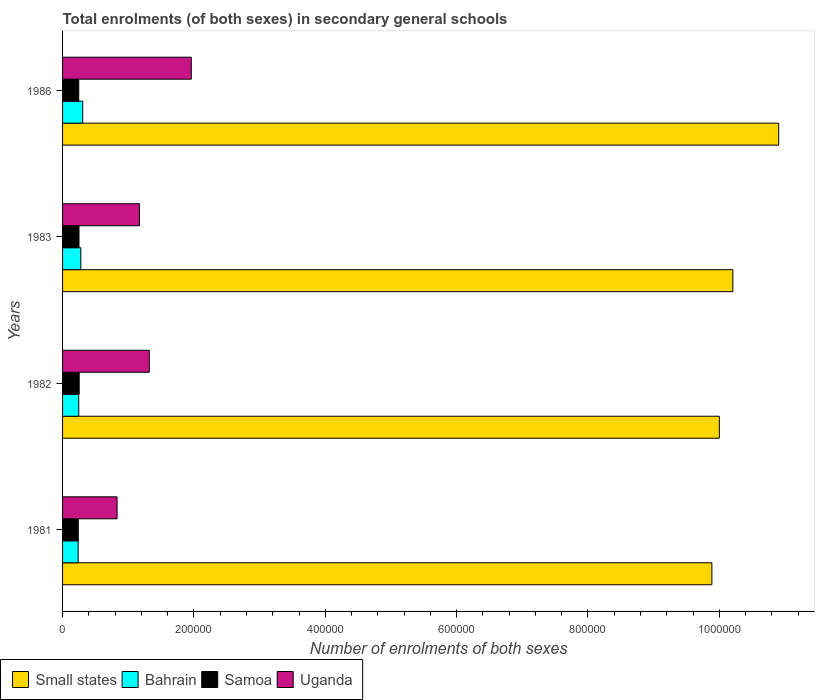Are the number of bars on each tick of the Y-axis equal?
Make the answer very short. Yes. How many bars are there on the 2nd tick from the top?
Provide a succinct answer. 4. What is the label of the 2nd group of bars from the top?
Keep it short and to the point. 1983. In how many cases, is the number of bars for a given year not equal to the number of legend labels?
Provide a short and direct response. 0. What is the number of enrolments in secondary schools in Uganda in 1983?
Offer a terse response. 1.17e+05. Across all years, what is the maximum number of enrolments in secondary schools in Small states?
Offer a very short reply. 1.09e+06. Across all years, what is the minimum number of enrolments in secondary schools in Samoa?
Your answer should be compact. 2.40e+04. In which year was the number of enrolments in secondary schools in Bahrain minimum?
Your answer should be very brief. 1981. What is the total number of enrolments in secondary schools in Samoa in the graph?
Give a very brief answer. 9.90e+04. What is the difference between the number of enrolments in secondary schools in Samoa in 1981 and that in 1983?
Provide a short and direct response. -1043. What is the difference between the number of enrolments in secondary schools in Uganda in 1981 and the number of enrolments in secondary schools in Small states in 1982?
Keep it short and to the point. -9.17e+05. What is the average number of enrolments in secondary schools in Small states per year?
Offer a very short reply. 1.02e+06. In the year 1981, what is the difference between the number of enrolments in secondary schools in Bahrain and number of enrolments in secondary schools in Small states?
Your answer should be very brief. -9.65e+05. What is the ratio of the number of enrolments in secondary schools in Uganda in 1983 to that in 1986?
Offer a very short reply. 0.6. Is the number of enrolments in secondary schools in Samoa in 1981 less than that in 1982?
Keep it short and to the point. Yes. What is the difference between the highest and the second highest number of enrolments in secondary schools in Small states?
Keep it short and to the point. 6.98e+04. What is the difference between the highest and the lowest number of enrolments in secondary schools in Samoa?
Provide a succinct answer. 1372. In how many years, is the number of enrolments in secondary schools in Bahrain greater than the average number of enrolments in secondary schools in Bahrain taken over all years?
Your answer should be compact. 2. Is the sum of the number of enrolments in secondary schools in Bahrain in 1981 and 1983 greater than the maximum number of enrolments in secondary schools in Uganda across all years?
Provide a succinct answer. No. What does the 3rd bar from the top in 1982 represents?
Your answer should be compact. Bahrain. What does the 4th bar from the bottom in 1983 represents?
Provide a succinct answer. Uganda. Is it the case that in every year, the sum of the number of enrolments in secondary schools in Bahrain and number of enrolments in secondary schools in Small states is greater than the number of enrolments in secondary schools in Samoa?
Ensure brevity in your answer.  Yes. How many years are there in the graph?
Provide a short and direct response. 4. What is the difference between two consecutive major ticks on the X-axis?
Make the answer very short. 2.00e+05. Does the graph contain grids?
Ensure brevity in your answer.  No. What is the title of the graph?
Give a very brief answer. Total enrolments (of both sexes) in secondary general schools. Does "Slovenia" appear as one of the legend labels in the graph?
Your answer should be compact. No. What is the label or title of the X-axis?
Ensure brevity in your answer.  Number of enrolments of both sexes. What is the Number of enrolments of both sexes of Small states in 1981?
Provide a succinct answer. 9.89e+05. What is the Number of enrolments of both sexes of Bahrain in 1981?
Ensure brevity in your answer.  2.37e+04. What is the Number of enrolments of both sexes of Samoa in 1981?
Keep it short and to the point. 2.40e+04. What is the Number of enrolments of both sexes of Uganda in 1981?
Provide a succinct answer. 8.30e+04. What is the Number of enrolments of both sexes of Small states in 1982?
Offer a terse response. 1.00e+06. What is the Number of enrolments of both sexes in Bahrain in 1982?
Keep it short and to the point. 2.46e+04. What is the Number of enrolments of both sexes of Samoa in 1982?
Provide a succinct answer. 2.53e+04. What is the Number of enrolments of both sexes in Uganda in 1982?
Ensure brevity in your answer.  1.32e+05. What is the Number of enrolments of both sexes of Small states in 1983?
Ensure brevity in your answer.  1.02e+06. What is the Number of enrolments of both sexes of Bahrain in 1983?
Provide a succinct answer. 2.78e+04. What is the Number of enrolments of both sexes in Samoa in 1983?
Your answer should be compact. 2.50e+04. What is the Number of enrolments of both sexes in Uganda in 1983?
Give a very brief answer. 1.17e+05. What is the Number of enrolments of both sexes of Small states in 1986?
Provide a succinct answer. 1.09e+06. What is the Number of enrolments of both sexes of Bahrain in 1986?
Ensure brevity in your answer.  3.07e+04. What is the Number of enrolments of both sexes in Samoa in 1986?
Give a very brief answer. 2.47e+04. What is the Number of enrolments of both sexes of Uganda in 1986?
Offer a terse response. 1.96e+05. Across all years, what is the maximum Number of enrolments of both sexes in Small states?
Provide a short and direct response. 1.09e+06. Across all years, what is the maximum Number of enrolments of both sexes in Bahrain?
Offer a terse response. 3.07e+04. Across all years, what is the maximum Number of enrolments of both sexes of Samoa?
Your response must be concise. 2.53e+04. Across all years, what is the maximum Number of enrolments of both sexes of Uganda?
Give a very brief answer. 1.96e+05. Across all years, what is the minimum Number of enrolments of both sexes in Small states?
Your response must be concise. 9.89e+05. Across all years, what is the minimum Number of enrolments of both sexes of Bahrain?
Your answer should be compact. 2.37e+04. Across all years, what is the minimum Number of enrolments of both sexes of Samoa?
Keep it short and to the point. 2.40e+04. Across all years, what is the minimum Number of enrolments of both sexes of Uganda?
Offer a very short reply. 8.30e+04. What is the total Number of enrolments of both sexes in Small states in the graph?
Your answer should be compact. 4.10e+06. What is the total Number of enrolments of both sexes in Bahrain in the graph?
Your answer should be very brief. 1.07e+05. What is the total Number of enrolments of both sexes of Samoa in the graph?
Keep it short and to the point. 9.90e+04. What is the total Number of enrolments of both sexes in Uganda in the graph?
Ensure brevity in your answer.  5.28e+05. What is the difference between the Number of enrolments of both sexes of Small states in 1981 and that in 1982?
Your answer should be compact. -1.13e+04. What is the difference between the Number of enrolments of both sexes in Bahrain in 1981 and that in 1982?
Provide a succinct answer. -929. What is the difference between the Number of enrolments of both sexes of Samoa in 1981 and that in 1982?
Your answer should be compact. -1372. What is the difference between the Number of enrolments of both sexes of Uganda in 1981 and that in 1982?
Provide a short and direct response. -4.91e+04. What is the difference between the Number of enrolments of both sexes in Small states in 1981 and that in 1983?
Offer a terse response. -3.19e+04. What is the difference between the Number of enrolments of both sexes in Bahrain in 1981 and that in 1983?
Give a very brief answer. -4067. What is the difference between the Number of enrolments of both sexes in Samoa in 1981 and that in 1983?
Your answer should be compact. -1043. What is the difference between the Number of enrolments of both sexes of Uganda in 1981 and that in 1983?
Your answer should be compact. -3.41e+04. What is the difference between the Number of enrolments of both sexes of Small states in 1981 and that in 1986?
Give a very brief answer. -1.02e+05. What is the difference between the Number of enrolments of both sexes of Bahrain in 1981 and that in 1986?
Ensure brevity in your answer.  -6989. What is the difference between the Number of enrolments of both sexes of Samoa in 1981 and that in 1986?
Provide a short and direct response. -690. What is the difference between the Number of enrolments of both sexes of Uganda in 1981 and that in 1986?
Your answer should be compact. -1.13e+05. What is the difference between the Number of enrolments of both sexes in Small states in 1982 and that in 1983?
Your answer should be compact. -2.06e+04. What is the difference between the Number of enrolments of both sexes in Bahrain in 1982 and that in 1983?
Provide a short and direct response. -3138. What is the difference between the Number of enrolments of both sexes of Samoa in 1982 and that in 1983?
Offer a terse response. 329. What is the difference between the Number of enrolments of both sexes of Uganda in 1982 and that in 1983?
Your answer should be compact. 1.50e+04. What is the difference between the Number of enrolments of both sexes in Small states in 1982 and that in 1986?
Your answer should be very brief. -9.04e+04. What is the difference between the Number of enrolments of both sexes in Bahrain in 1982 and that in 1986?
Keep it short and to the point. -6060. What is the difference between the Number of enrolments of both sexes of Samoa in 1982 and that in 1986?
Provide a short and direct response. 682. What is the difference between the Number of enrolments of both sexes of Uganda in 1982 and that in 1986?
Offer a terse response. -6.40e+04. What is the difference between the Number of enrolments of both sexes of Small states in 1983 and that in 1986?
Offer a terse response. -6.98e+04. What is the difference between the Number of enrolments of both sexes of Bahrain in 1983 and that in 1986?
Your answer should be very brief. -2922. What is the difference between the Number of enrolments of both sexes in Samoa in 1983 and that in 1986?
Offer a very short reply. 353. What is the difference between the Number of enrolments of both sexes of Uganda in 1983 and that in 1986?
Offer a very short reply. -7.89e+04. What is the difference between the Number of enrolments of both sexes in Small states in 1981 and the Number of enrolments of both sexes in Bahrain in 1982?
Ensure brevity in your answer.  9.64e+05. What is the difference between the Number of enrolments of both sexes of Small states in 1981 and the Number of enrolments of both sexes of Samoa in 1982?
Your answer should be very brief. 9.63e+05. What is the difference between the Number of enrolments of both sexes in Small states in 1981 and the Number of enrolments of both sexes in Uganda in 1982?
Provide a short and direct response. 8.57e+05. What is the difference between the Number of enrolments of both sexes in Bahrain in 1981 and the Number of enrolments of both sexes in Samoa in 1982?
Make the answer very short. -1623. What is the difference between the Number of enrolments of both sexes of Bahrain in 1981 and the Number of enrolments of both sexes of Uganda in 1982?
Keep it short and to the point. -1.08e+05. What is the difference between the Number of enrolments of both sexes of Samoa in 1981 and the Number of enrolments of both sexes of Uganda in 1982?
Your response must be concise. -1.08e+05. What is the difference between the Number of enrolments of both sexes of Small states in 1981 and the Number of enrolments of both sexes of Bahrain in 1983?
Your response must be concise. 9.61e+05. What is the difference between the Number of enrolments of both sexes in Small states in 1981 and the Number of enrolments of both sexes in Samoa in 1983?
Keep it short and to the point. 9.64e+05. What is the difference between the Number of enrolments of both sexes in Small states in 1981 and the Number of enrolments of both sexes in Uganda in 1983?
Your response must be concise. 8.72e+05. What is the difference between the Number of enrolments of both sexes of Bahrain in 1981 and the Number of enrolments of both sexes of Samoa in 1983?
Provide a succinct answer. -1294. What is the difference between the Number of enrolments of both sexes in Bahrain in 1981 and the Number of enrolments of both sexes in Uganda in 1983?
Offer a terse response. -9.34e+04. What is the difference between the Number of enrolments of both sexes in Samoa in 1981 and the Number of enrolments of both sexes in Uganda in 1983?
Your answer should be compact. -9.31e+04. What is the difference between the Number of enrolments of both sexes in Small states in 1981 and the Number of enrolments of both sexes in Bahrain in 1986?
Give a very brief answer. 9.58e+05. What is the difference between the Number of enrolments of both sexes of Small states in 1981 and the Number of enrolments of both sexes of Samoa in 1986?
Give a very brief answer. 9.64e+05. What is the difference between the Number of enrolments of both sexes of Small states in 1981 and the Number of enrolments of both sexes of Uganda in 1986?
Offer a terse response. 7.93e+05. What is the difference between the Number of enrolments of both sexes in Bahrain in 1981 and the Number of enrolments of both sexes in Samoa in 1986?
Provide a succinct answer. -941. What is the difference between the Number of enrolments of both sexes in Bahrain in 1981 and the Number of enrolments of both sexes in Uganda in 1986?
Your answer should be very brief. -1.72e+05. What is the difference between the Number of enrolments of both sexes of Samoa in 1981 and the Number of enrolments of both sexes of Uganda in 1986?
Ensure brevity in your answer.  -1.72e+05. What is the difference between the Number of enrolments of both sexes in Small states in 1982 and the Number of enrolments of both sexes in Bahrain in 1983?
Your response must be concise. 9.72e+05. What is the difference between the Number of enrolments of both sexes of Small states in 1982 and the Number of enrolments of both sexes of Samoa in 1983?
Keep it short and to the point. 9.75e+05. What is the difference between the Number of enrolments of both sexes of Small states in 1982 and the Number of enrolments of both sexes of Uganda in 1983?
Your answer should be compact. 8.83e+05. What is the difference between the Number of enrolments of both sexes in Bahrain in 1982 and the Number of enrolments of both sexes in Samoa in 1983?
Ensure brevity in your answer.  -365. What is the difference between the Number of enrolments of both sexes in Bahrain in 1982 and the Number of enrolments of both sexes in Uganda in 1983?
Ensure brevity in your answer.  -9.24e+04. What is the difference between the Number of enrolments of both sexes in Samoa in 1982 and the Number of enrolments of both sexes in Uganda in 1983?
Give a very brief answer. -9.17e+04. What is the difference between the Number of enrolments of both sexes in Small states in 1982 and the Number of enrolments of both sexes in Bahrain in 1986?
Make the answer very short. 9.69e+05. What is the difference between the Number of enrolments of both sexes of Small states in 1982 and the Number of enrolments of both sexes of Samoa in 1986?
Offer a very short reply. 9.75e+05. What is the difference between the Number of enrolments of both sexes in Small states in 1982 and the Number of enrolments of both sexes in Uganda in 1986?
Make the answer very short. 8.04e+05. What is the difference between the Number of enrolments of both sexes in Bahrain in 1982 and the Number of enrolments of both sexes in Uganda in 1986?
Give a very brief answer. -1.71e+05. What is the difference between the Number of enrolments of both sexes of Samoa in 1982 and the Number of enrolments of both sexes of Uganda in 1986?
Keep it short and to the point. -1.71e+05. What is the difference between the Number of enrolments of both sexes in Small states in 1983 and the Number of enrolments of both sexes in Bahrain in 1986?
Your answer should be compact. 9.90e+05. What is the difference between the Number of enrolments of both sexes of Small states in 1983 and the Number of enrolments of both sexes of Samoa in 1986?
Your answer should be very brief. 9.96e+05. What is the difference between the Number of enrolments of both sexes of Small states in 1983 and the Number of enrolments of both sexes of Uganda in 1986?
Offer a terse response. 8.25e+05. What is the difference between the Number of enrolments of both sexes of Bahrain in 1983 and the Number of enrolments of both sexes of Samoa in 1986?
Give a very brief answer. 3126. What is the difference between the Number of enrolments of both sexes in Bahrain in 1983 and the Number of enrolments of both sexes in Uganda in 1986?
Provide a short and direct response. -1.68e+05. What is the difference between the Number of enrolments of both sexes in Samoa in 1983 and the Number of enrolments of both sexes in Uganda in 1986?
Make the answer very short. -1.71e+05. What is the average Number of enrolments of both sexes in Small states per year?
Offer a very short reply. 1.02e+06. What is the average Number of enrolments of both sexes of Bahrain per year?
Offer a very short reply. 2.67e+04. What is the average Number of enrolments of both sexes in Samoa per year?
Ensure brevity in your answer.  2.47e+04. What is the average Number of enrolments of both sexes in Uganda per year?
Keep it short and to the point. 1.32e+05. In the year 1981, what is the difference between the Number of enrolments of both sexes in Small states and Number of enrolments of both sexes in Bahrain?
Your answer should be compact. 9.65e+05. In the year 1981, what is the difference between the Number of enrolments of both sexes in Small states and Number of enrolments of both sexes in Samoa?
Your answer should be very brief. 9.65e+05. In the year 1981, what is the difference between the Number of enrolments of both sexes of Small states and Number of enrolments of both sexes of Uganda?
Keep it short and to the point. 9.06e+05. In the year 1981, what is the difference between the Number of enrolments of both sexes of Bahrain and Number of enrolments of both sexes of Samoa?
Provide a short and direct response. -251. In the year 1981, what is the difference between the Number of enrolments of both sexes of Bahrain and Number of enrolments of both sexes of Uganda?
Offer a terse response. -5.93e+04. In the year 1981, what is the difference between the Number of enrolments of both sexes of Samoa and Number of enrolments of both sexes of Uganda?
Make the answer very short. -5.90e+04. In the year 1982, what is the difference between the Number of enrolments of both sexes in Small states and Number of enrolments of both sexes in Bahrain?
Provide a short and direct response. 9.75e+05. In the year 1982, what is the difference between the Number of enrolments of both sexes in Small states and Number of enrolments of both sexes in Samoa?
Your response must be concise. 9.75e+05. In the year 1982, what is the difference between the Number of enrolments of both sexes of Small states and Number of enrolments of both sexes of Uganda?
Your answer should be very brief. 8.68e+05. In the year 1982, what is the difference between the Number of enrolments of both sexes in Bahrain and Number of enrolments of both sexes in Samoa?
Your answer should be very brief. -694. In the year 1982, what is the difference between the Number of enrolments of both sexes of Bahrain and Number of enrolments of both sexes of Uganda?
Provide a succinct answer. -1.07e+05. In the year 1982, what is the difference between the Number of enrolments of both sexes of Samoa and Number of enrolments of both sexes of Uganda?
Provide a short and direct response. -1.07e+05. In the year 1983, what is the difference between the Number of enrolments of both sexes of Small states and Number of enrolments of both sexes of Bahrain?
Make the answer very short. 9.93e+05. In the year 1983, what is the difference between the Number of enrolments of both sexes in Small states and Number of enrolments of both sexes in Samoa?
Your response must be concise. 9.96e+05. In the year 1983, what is the difference between the Number of enrolments of both sexes of Small states and Number of enrolments of both sexes of Uganda?
Provide a short and direct response. 9.04e+05. In the year 1983, what is the difference between the Number of enrolments of both sexes of Bahrain and Number of enrolments of both sexes of Samoa?
Your response must be concise. 2773. In the year 1983, what is the difference between the Number of enrolments of both sexes in Bahrain and Number of enrolments of both sexes in Uganda?
Make the answer very short. -8.93e+04. In the year 1983, what is the difference between the Number of enrolments of both sexes in Samoa and Number of enrolments of both sexes in Uganda?
Your answer should be compact. -9.21e+04. In the year 1986, what is the difference between the Number of enrolments of both sexes of Small states and Number of enrolments of both sexes of Bahrain?
Provide a short and direct response. 1.06e+06. In the year 1986, what is the difference between the Number of enrolments of both sexes in Small states and Number of enrolments of both sexes in Samoa?
Give a very brief answer. 1.07e+06. In the year 1986, what is the difference between the Number of enrolments of both sexes of Small states and Number of enrolments of both sexes of Uganda?
Give a very brief answer. 8.94e+05. In the year 1986, what is the difference between the Number of enrolments of both sexes of Bahrain and Number of enrolments of both sexes of Samoa?
Make the answer very short. 6048. In the year 1986, what is the difference between the Number of enrolments of both sexes of Bahrain and Number of enrolments of both sexes of Uganda?
Your answer should be very brief. -1.65e+05. In the year 1986, what is the difference between the Number of enrolments of both sexes of Samoa and Number of enrolments of both sexes of Uganda?
Keep it short and to the point. -1.71e+05. What is the ratio of the Number of enrolments of both sexes of Small states in 1981 to that in 1982?
Your answer should be very brief. 0.99. What is the ratio of the Number of enrolments of both sexes in Bahrain in 1981 to that in 1982?
Your answer should be compact. 0.96. What is the ratio of the Number of enrolments of both sexes of Samoa in 1981 to that in 1982?
Ensure brevity in your answer.  0.95. What is the ratio of the Number of enrolments of both sexes of Uganda in 1981 to that in 1982?
Your answer should be compact. 0.63. What is the ratio of the Number of enrolments of both sexes in Small states in 1981 to that in 1983?
Offer a very short reply. 0.97. What is the ratio of the Number of enrolments of both sexes of Bahrain in 1981 to that in 1983?
Make the answer very short. 0.85. What is the ratio of the Number of enrolments of both sexes of Uganda in 1981 to that in 1983?
Make the answer very short. 0.71. What is the ratio of the Number of enrolments of both sexes in Small states in 1981 to that in 1986?
Your response must be concise. 0.91. What is the ratio of the Number of enrolments of both sexes of Bahrain in 1981 to that in 1986?
Your answer should be very brief. 0.77. What is the ratio of the Number of enrolments of both sexes in Samoa in 1981 to that in 1986?
Ensure brevity in your answer.  0.97. What is the ratio of the Number of enrolments of both sexes in Uganda in 1981 to that in 1986?
Give a very brief answer. 0.42. What is the ratio of the Number of enrolments of both sexes in Small states in 1982 to that in 1983?
Provide a short and direct response. 0.98. What is the ratio of the Number of enrolments of both sexes of Bahrain in 1982 to that in 1983?
Offer a terse response. 0.89. What is the ratio of the Number of enrolments of both sexes of Samoa in 1982 to that in 1983?
Offer a very short reply. 1.01. What is the ratio of the Number of enrolments of both sexes in Uganda in 1982 to that in 1983?
Your response must be concise. 1.13. What is the ratio of the Number of enrolments of both sexes in Small states in 1982 to that in 1986?
Ensure brevity in your answer.  0.92. What is the ratio of the Number of enrolments of both sexes of Bahrain in 1982 to that in 1986?
Make the answer very short. 0.8. What is the ratio of the Number of enrolments of both sexes of Samoa in 1982 to that in 1986?
Make the answer very short. 1.03. What is the ratio of the Number of enrolments of both sexes in Uganda in 1982 to that in 1986?
Make the answer very short. 0.67. What is the ratio of the Number of enrolments of both sexes in Small states in 1983 to that in 1986?
Offer a terse response. 0.94. What is the ratio of the Number of enrolments of both sexes in Bahrain in 1983 to that in 1986?
Provide a succinct answer. 0.9. What is the ratio of the Number of enrolments of both sexes of Samoa in 1983 to that in 1986?
Your response must be concise. 1.01. What is the ratio of the Number of enrolments of both sexes in Uganda in 1983 to that in 1986?
Make the answer very short. 0.6. What is the difference between the highest and the second highest Number of enrolments of both sexes of Small states?
Provide a short and direct response. 6.98e+04. What is the difference between the highest and the second highest Number of enrolments of both sexes of Bahrain?
Provide a succinct answer. 2922. What is the difference between the highest and the second highest Number of enrolments of both sexes in Samoa?
Ensure brevity in your answer.  329. What is the difference between the highest and the second highest Number of enrolments of both sexes in Uganda?
Your response must be concise. 6.40e+04. What is the difference between the highest and the lowest Number of enrolments of both sexes of Small states?
Provide a short and direct response. 1.02e+05. What is the difference between the highest and the lowest Number of enrolments of both sexes in Bahrain?
Offer a very short reply. 6989. What is the difference between the highest and the lowest Number of enrolments of both sexes of Samoa?
Provide a succinct answer. 1372. What is the difference between the highest and the lowest Number of enrolments of both sexes of Uganda?
Provide a short and direct response. 1.13e+05. 